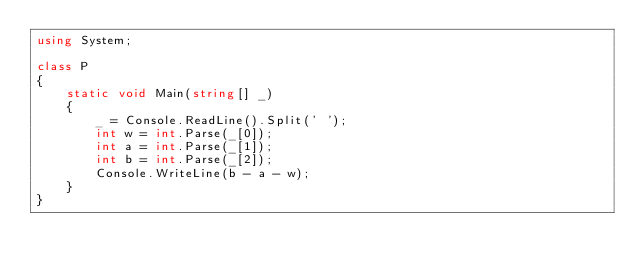Convert code to text. <code><loc_0><loc_0><loc_500><loc_500><_C#_>using System;

class P
{
    static void Main(string[] _)
    {
        _ = Console.ReadLine().Split(' ');
        int w = int.Parse(_[0]);
        int a = int.Parse(_[1]);
        int b = int.Parse(_[2]);
        Console.WriteLine(b - a - w);
    }
}
</code> 